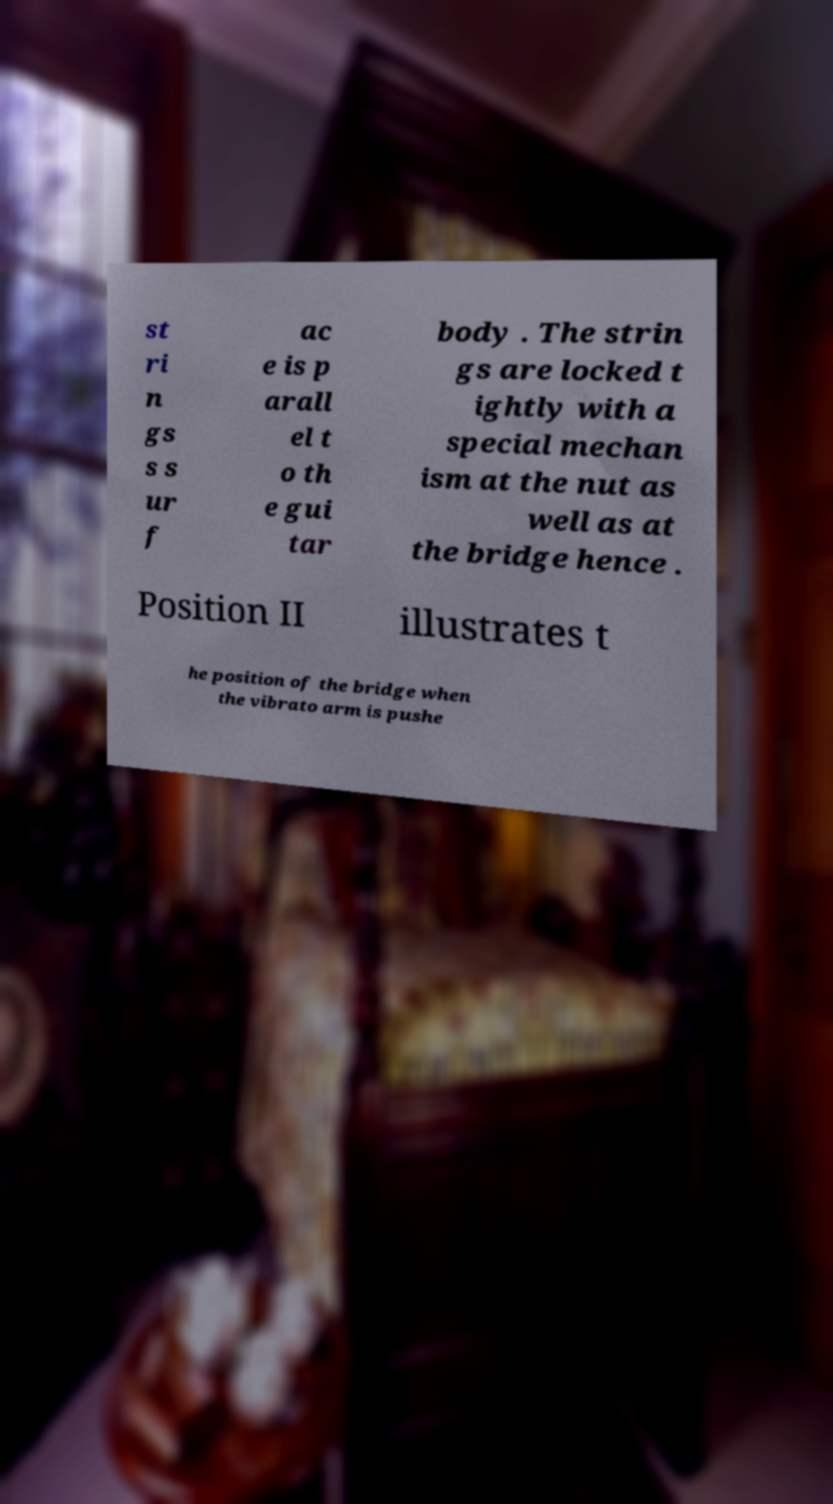Can you read and provide the text displayed in the image?This photo seems to have some interesting text. Can you extract and type it out for me? st ri n gs s s ur f ac e is p arall el t o th e gui tar body . The strin gs are locked t ightly with a special mechan ism at the nut as well as at the bridge hence . Position II illustrates t he position of the bridge when the vibrato arm is pushe 